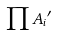<formula> <loc_0><loc_0><loc_500><loc_500>\prod { A _ { i } } ^ { \prime }</formula> 